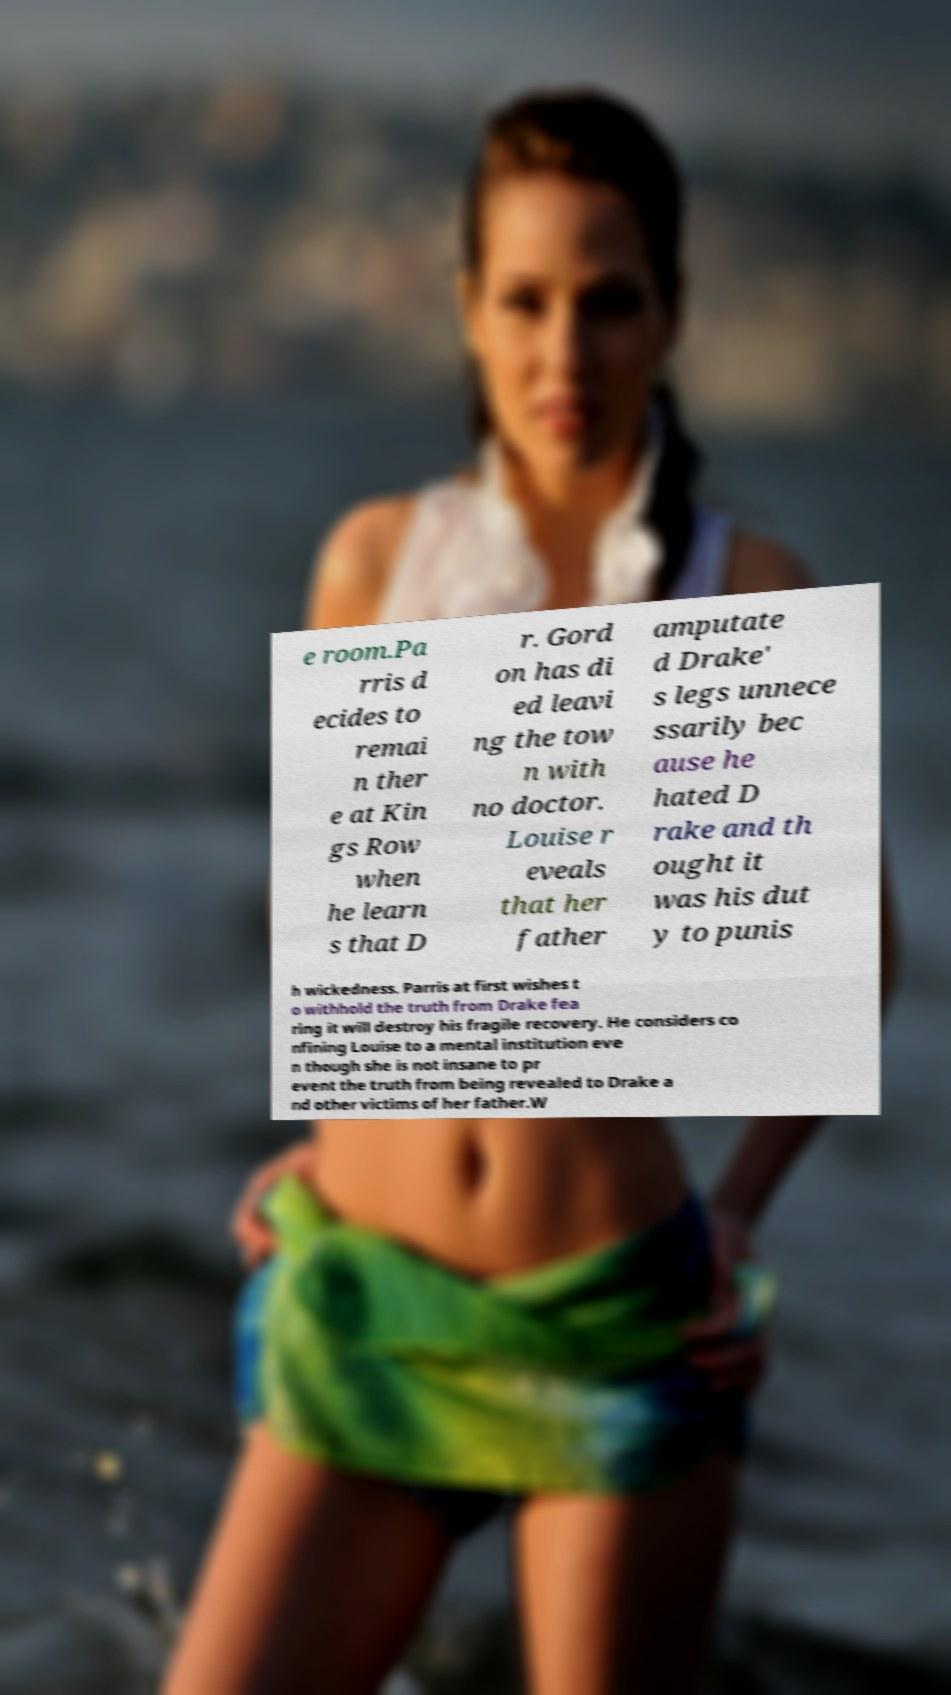What messages or text are displayed in this image? I need them in a readable, typed format. e room.Pa rris d ecides to remai n ther e at Kin gs Row when he learn s that D r. Gord on has di ed leavi ng the tow n with no doctor. Louise r eveals that her father amputate d Drake' s legs unnece ssarily bec ause he hated D rake and th ought it was his dut y to punis h wickedness. Parris at first wishes t o withhold the truth from Drake fea ring it will destroy his fragile recovery. He considers co nfining Louise to a mental institution eve n though she is not insane to pr event the truth from being revealed to Drake a nd other victims of her father.W 